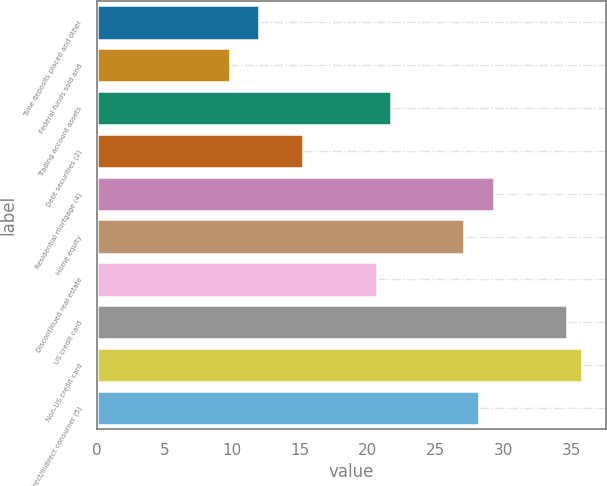Convert chart to OTSL. <chart><loc_0><loc_0><loc_500><loc_500><bar_chart><fcel>Time deposits placed and other<fcel>Federal funds sold and<fcel>Trading account assets<fcel>Debt securities (2)<fcel>Residential mortgage (4)<fcel>Home equity<fcel>Discontinued real estate<fcel>US credit card<fcel>Non-US credit card<fcel>Direct/Indirect consumer (5)<nl><fcel>12<fcel>9.84<fcel>21.72<fcel>15.24<fcel>29.28<fcel>27.12<fcel>20.64<fcel>34.68<fcel>35.76<fcel>28.2<nl></chart> 